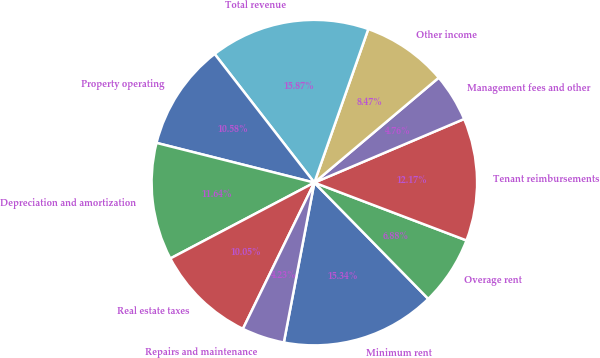Convert chart to OTSL. <chart><loc_0><loc_0><loc_500><loc_500><pie_chart><fcel>Minimum rent<fcel>Overage rent<fcel>Tenant reimbursements<fcel>Management fees and other<fcel>Other income<fcel>Total revenue<fcel>Property operating<fcel>Depreciation and amortization<fcel>Real estate taxes<fcel>Repairs and maintenance<nl><fcel>15.34%<fcel>6.88%<fcel>12.17%<fcel>4.76%<fcel>8.47%<fcel>15.87%<fcel>10.58%<fcel>11.64%<fcel>10.05%<fcel>4.23%<nl></chart> 